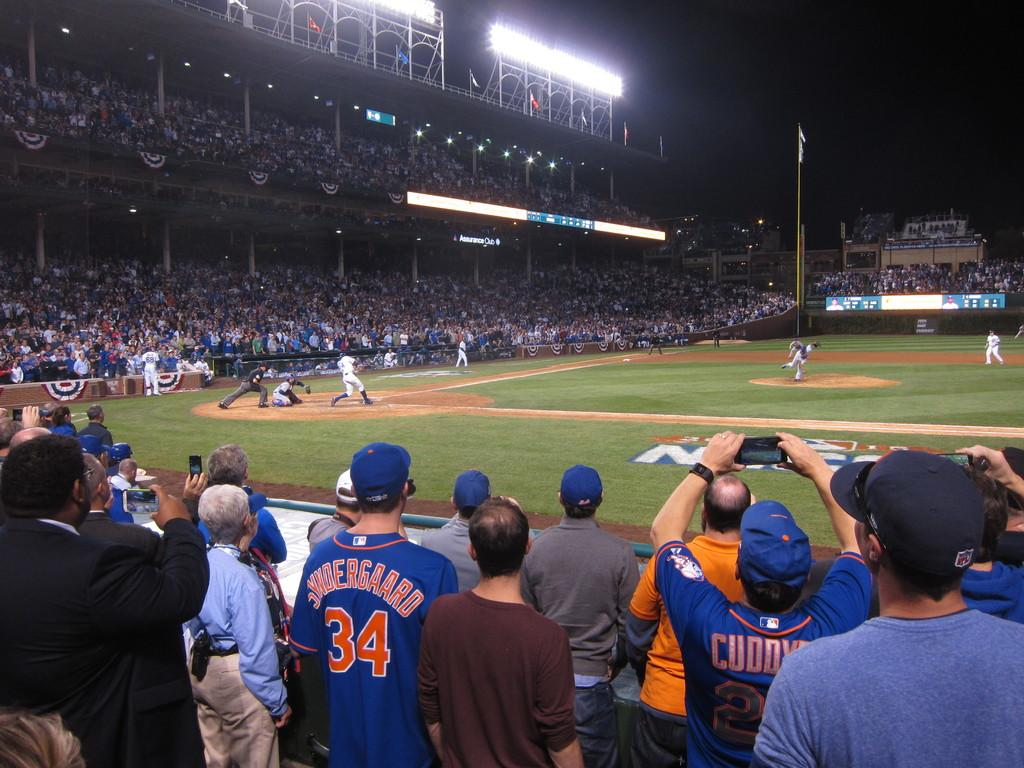Provide a one-sentence caption for the provided image. A crowd watching the baseball game, one of the fans is wearing a jersey with the number 34 on it. 